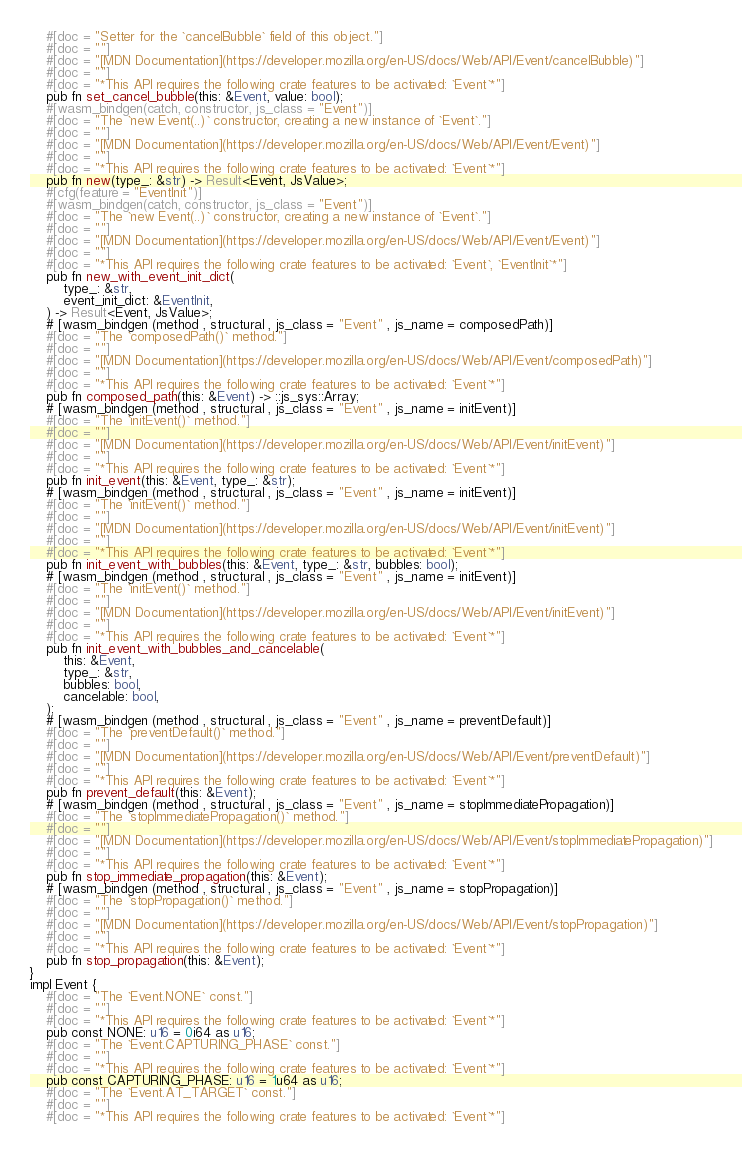Convert code to text. <code><loc_0><loc_0><loc_500><loc_500><_Rust_>    #[doc = "Setter for the `cancelBubble` field of this object."]
    #[doc = ""]
    #[doc = "[MDN Documentation](https://developer.mozilla.org/en-US/docs/Web/API/Event/cancelBubble)"]
    #[doc = ""]
    #[doc = "*This API requires the following crate features to be activated: `Event`*"]
    pub fn set_cancel_bubble(this: &Event, value: bool);
    #[wasm_bindgen(catch, constructor, js_class = "Event")]
    #[doc = "The `new Event(..)` constructor, creating a new instance of `Event`."]
    #[doc = ""]
    #[doc = "[MDN Documentation](https://developer.mozilla.org/en-US/docs/Web/API/Event/Event)"]
    #[doc = ""]
    #[doc = "*This API requires the following crate features to be activated: `Event`*"]
    pub fn new(type_: &str) -> Result<Event, JsValue>;
    #[cfg(feature = "EventInit")]
    #[wasm_bindgen(catch, constructor, js_class = "Event")]
    #[doc = "The `new Event(..)` constructor, creating a new instance of `Event`."]
    #[doc = ""]
    #[doc = "[MDN Documentation](https://developer.mozilla.org/en-US/docs/Web/API/Event/Event)"]
    #[doc = ""]
    #[doc = "*This API requires the following crate features to be activated: `Event`, `EventInit`*"]
    pub fn new_with_event_init_dict(
        type_: &str,
        event_init_dict: &EventInit,
    ) -> Result<Event, JsValue>;
    # [wasm_bindgen (method , structural , js_class = "Event" , js_name = composedPath)]
    #[doc = "The `composedPath()` method."]
    #[doc = ""]
    #[doc = "[MDN Documentation](https://developer.mozilla.org/en-US/docs/Web/API/Event/composedPath)"]
    #[doc = ""]
    #[doc = "*This API requires the following crate features to be activated: `Event`*"]
    pub fn composed_path(this: &Event) -> ::js_sys::Array;
    # [wasm_bindgen (method , structural , js_class = "Event" , js_name = initEvent)]
    #[doc = "The `initEvent()` method."]
    #[doc = ""]
    #[doc = "[MDN Documentation](https://developer.mozilla.org/en-US/docs/Web/API/Event/initEvent)"]
    #[doc = ""]
    #[doc = "*This API requires the following crate features to be activated: `Event`*"]
    pub fn init_event(this: &Event, type_: &str);
    # [wasm_bindgen (method , structural , js_class = "Event" , js_name = initEvent)]
    #[doc = "The `initEvent()` method."]
    #[doc = ""]
    #[doc = "[MDN Documentation](https://developer.mozilla.org/en-US/docs/Web/API/Event/initEvent)"]
    #[doc = ""]
    #[doc = "*This API requires the following crate features to be activated: `Event`*"]
    pub fn init_event_with_bubbles(this: &Event, type_: &str, bubbles: bool);
    # [wasm_bindgen (method , structural , js_class = "Event" , js_name = initEvent)]
    #[doc = "The `initEvent()` method."]
    #[doc = ""]
    #[doc = "[MDN Documentation](https://developer.mozilla.org/en-US/docs/Web/API/Event/initEvent)"]
    #[doc = ""]
    #[doc = "*This API requires the following crate features to be activated: `Event`*"]
    pub fn init_event_with_bubbles_and_cancelable(
        this: &Event,
        type_: &str,
        bubbles: bool,
        cancelable: bool,
    );
    # [wasm_bindgen (method , structural , js_class = "Event" , js_name = preventDefault)]
    #[doc = "The `preventDefault()` method."]
    #[doc = ""]
    #[doc = "[MDN Documentation](https://developer.mozilla.org/en-US/docs/Web/API/Event/preventDefault)"]
    #[doc = ""]
    #[doc = "*This API requires the following crate features to be activated: `Event`*"]
    pub fn prevent_default(this: &Event);
    # [wasm_bindgen (method , structural , js_class = "Event" , js_name = stopImmediatePropagation)]
    #[doc = "The `stopImmediatePropagation()` method."]
    #[doc = ""]
    #[doc = "[MDN Documentation](https://developer.mozilla.org/en-US/docs/Web/API/Event/stopImmediatePropagation)"]
    #[doc = ""]
    #[doc = "*This API requires the following crate features to be activated: `Event`*"]
    pub fn stop_immediate_propagation(this: &Event);
    # [wasm_bindgen (method , structural , js_class = "Event" , js_name = stopPropagation)]
    #[doc = "The `stopPropagation()` method."]
    #[doc = ""]
    #[doc = "[MDN Documentation](https://developer.mozilla.org/en-US/docs/Web/API/Event/stopPropagation)"]
    #[doc = ""]
    #[doc = "*This API requires the following crate features to be activated: `Event`*"]
    pub fn stop_propagation(this: &Event);
}
impl Event {
    #[doc = "The `Event.NONE` const."]
    #[doc = ""]
    #[doc = "*This API requires the following crate features to be activated: `Event`*"]
    pub const NONE: u16 = 0i64 as u16;
    #[doc = "The `Event.CAPTURING_PHASE` const."]
    #[doc = ""]
    #[doc = "*This API requires the following crate features to be activated: `Event`*"]
    pub const CAPTURING_PHASE: u16 = 1u64 as u16;
    #[doc = "The `Event.AT_TARGET` const."]
    #[doc = ""]
    #[doc = "*This API requires the following crate features to be activated: `Event`*"]</code> 